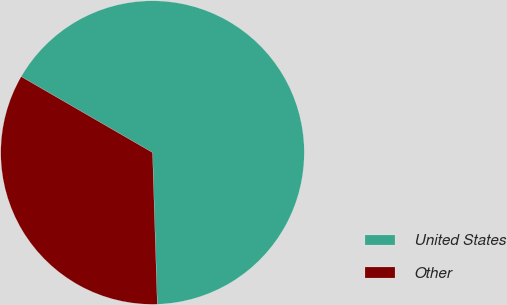Convert chart. <chart><loc_0><loc_0><loc_500><loc_500><pie_chart><fcel>United States<fcel>Other<nl><fcel>66.16%<fcel>33.84%<nl></chart> 